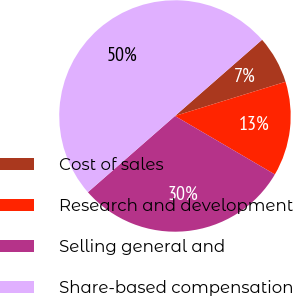Convert chart to OTSL. <chart><loc_0><loc_0><loc_500><loc_500><pie_chart><fcel>Cost of sales<fcel>Research and development<fcel>Selling general and<fcel>Share-based compensation<nl><fcel>6.67%<fcel>13.2%<fcel>30.13%<fcel>50.0%<nl></chart> 